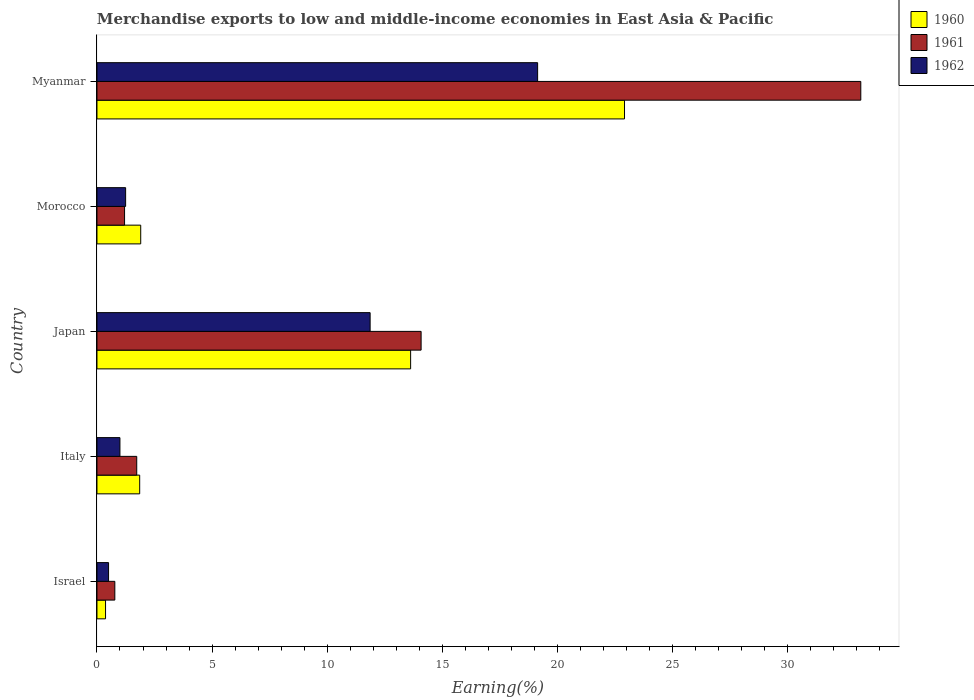How many different coloured bars are there?
Give a very brief answer. 3. How many groups of bars are there?
Provide a short and direct response. 5. How many bars are there on the 2nd tick from the top?
Your response must be concise. 3. How many bars are there on the 2nd tick from the bottom?
Your answer should be compact. 3. In how many cases, is the number of bars for a given country not equal to the number of legend labels?
Provide a succinct answer. 0. What is the percentage of amount earned from merchandise exports in 1961 in Myanmar?
Ensure brevity in your answer.  33.19. Across all countries, what is the maximum percentage of amount earned from merchandise exports in 1960?
Your answer should be very brief. 22.92. Across all countries, what is the minimum percentage of amount earned from merchandise exports in 1960?
Make the answer very short. 0.37. In which country was the percentage of amount earned from merchandise exports in 1960 maximum?
Your response must be concise. Myanmar. In which country was the percentage of amount earned from merchandise exports in 1960 minimum?
Provide a short and direct response. Israel. What is the total percentage of amount earned from merchandise exports in 1960 in the graph?
Your answer should be compact. 40.68. What is the difference between the percentage of amount earned from merchandise exports in 1960 in Italy and that in Japan?
Your answer should be compact. -11.77. What is the difference between the percentage of amount earned from merchandise exports in 1961 in Israel and the percentage of amount earned from merchandise exports in 1962 in Morocco?
Offer a terse response. -0.47. What is the average percentage of amount earned from merchandise exports in 1960 per country?
Make the answer very short. 8.14. What is the difference between the percentage of amount earned from merchandise exports in 1961 and percentage of amount earned from merchandise exports in 1962 in Japan?
Provide a short and direct response. 2.22. In how many countries, is the percentage of amount earned from merchandise exports in 1962 greater than 4 %?
Provide a short and direct response. 2. What is the ratio of the percentage of amount earned from merchandise exports in 1962 in Italy to that in Morocco?
Keep it short and to the point. 0.8. Is the percentage of amount earned from merchandise exports in 1962 in Morocco less than that in Myanmar?
Ensure brevity in your answer.  Yes. Is the difference between the percentage of amount earned from merchandise exports in 1961 in Israel and Italy greater than the difference between the percentage of amount earned from merchandise exports in 1962 in Israel and Italy?
Keep it short and to the point. No. What is the difference between the highest and the second highest percentage of amount earned from merchandise exports in 1962?
Provide a short and direct response. 7.28. What is the difference between the highest and the lowest percentage of amount earned from merchandise exports in 1961?
Keep it short and to the point. 32.41. In how many countries, is the percentage of amount earned from merchandise exports in 1960 greater than the average percentage of amount earned from merchandise exports in 1960 taken over all countries?
Keep it short and to the point. 2. Are all the bars in the graph horizontal?
Keep it short and to the point. Yes. What is the difference between two consecutive major ticks on the X-axis?
Offer a very short reply. 5. Are the values on the major ticks of X-axis written in scientific E-notation?
Your answer should be compact. No. How many legend labels are there?
Make the answer very short. 3. How are the legend labels stacked?
Provide a short and direct response. Vertical. What is the title of the graph?
Keep it short and to the point. Merchandise exports to low and middle-income economies in East Asia & Pacific. What is the label or title of the X-axis?
Keep it short and to the point. Earning(%). What is the label or title of the Y-axis?
Offer a very short reply. Country. What is the Earning(%) of 1960 in Israel?
Give a very brief answer. 0.37. What is the Earning(%) in 1961 in Israel?
Provide a succinct answer. 0.78. What is the Earning(%) in 1962 in Israel?
Keep it short and to the point. 0.5. What is the Earning(%) of 1960 in Italy?
Provide a short and direct response. 1.86. What is the Earning(%) in 1961 in Italy?
Provide a short and direct response. 1.73. What is the Earning(%) of 1962 in Italy?
Ensure brevity in your answer.  1. What is the Earning(%) of 1960 in Japan?
Give a very brief answer. 13.63. What is the Earning(%) in 1961 in Japan?
Offer a terse response. 14.09. What is the Earning(%) of 1962 in Japan?
Your response must be concise. 11.87. What is the Earning(%) of 1960 in Morocco?
Your answer should be compact. 1.9. What is the Earning(%) in 1961 in Morocco?
Your answer should be compact. 1.2. What is the Earning(%) in 1962 in Morocco?
Your answer should be very brief. 1.25. What is the Earning(%) of 1960 in Myanmar?
Provide a short and direct response. 22.92. What is the Earning(%) in 1961 in Myanmar?
Offer a terse response. 33.19. What is the Earning(%) of 1962 in Myanmar?
Provide a short and direct response. 19.15. Across all countries, what is the maximum Earning(%) of 1960?
Your answer should be very brief. 22.92. Across all countries, what is the maximum Earning(%) of 1961?
Your answer should be very brief. 33.19. Across all countries, what is the maximum Earning(%) of 1962?
Your response must be concise. 19.15. Across all countries, what is the minimum Earning(%) in 1960?
Make the answer very short. 0.37. Across all countries, what is the minimum Earning(%) of 1961?
Give a very brief answer. 0.78. Across all countries, what is the minimum Earning(%) in 1962?
Keep it short and to the point. 0.5. What is the total Earning(%) of 1960 in the graph?
Your response must be concise. 40.68. What is the total Earning(%) of 1961 in the graph?
Your answer should be very brief. 50.98. What is the total Earning(%) in 1962 in the graph?
Your answer should be compact. 33.77. What is the difference between the Earning(%) of 1960 in Israel and that in Italy?
Give a very brief answer. -1.48. What is the difference between the Earning(%) of 1961 in Israel and that in Italy?
Keep it short and to the point. -0.95. What is the difference between the Earning(%) of 1962 in Israel and that in Italy?
Provide a succinct answer. -0.49. What is the difference between the Earning(%) of 1960 in Israel and that in Japan?
Provide a short and direct response. -13.26. What is the difference between the Earning(%) of 1961 in Israel and that in Japan?
Provide a succinct answer. -13.31. What is the difference between the Earning(%) in 1962 in Israel and that in Japan?
Offer a very short reply. -11.37. What is the difference between the Earning(%) in 1960 in Israel and that in Morocco?
Make the answer very short. -1.53. What is the difference between the Earning(%) in 1961 in Israel and that in Morocco?
Your answer should be very brief. -0.42. What is the difference between the Earning(%) of 1962 in Israel and that in Morocco?
Offer a terse response. -0.74. What is the difference between the Earning(%) of 1960 in Israel and that in Myanmar?
Make the answer very short. -22.55. What is the difference between the Earning(%) of 1961 in Israel and that in Myanmar?
Provide a short and direct response. -32.41. What is the difference between the Earning(%) in 1962 in Israel and that in Myanmar?
Your response must be concise. -18.64. What is the difference between the Earning(%) of 1960 in Italy and that in Japan?
Ensure brevity in your answer.  -11.77. What is the difference between the Earning(%) of 1961 in Italy and that in Japan?
Provide a short and direct response. -12.36. What is the difference between the Earning(%) of 1962 in Italy and that in Japan?
Your answer should be compact. -10.87. What is the difference between the Earning(%) in 1960 in Italy and that in Morocco?
Make the answer very short. -0.04. What is the difference between the Earning(%) of 1961 in Italy and that in Morocco?
Give a very brief answer. 0.53. What is the difference between the Earning(%) in 1962 in Italy and that in Morocco?
Your answer should be very brief. -0.25. What is the difference between the Earning(%) in 1960 in Italy and that in Myanmar?
Give a very brief answer. -21.07. What is the difference between the Earning(%) of 1961 in Italy and that in Myanmar?
Give a very brief answer. -31.46. What is the difference between the Earning(%) of 1962 in Italy and that in Myanmar?
Offer a very short reply. -18.15. What is the difference between the Earning(%) of 1960 in Japan and that in Morocco?
Ensure brevity in your answer.  11.73. What is the difference between the Earning(%) in 1961 in Japan and that in Morocco?
Offer a very short reply. 12.89. What is the difference between the Earning(%) of 1962 in Japan and that in Morocco?
Offer a very short reply. 10.62. What is the difference between the Earning(%) of 1960 in Japan and that in Myanmar?
Your response must be concise. -9.29. What is the difference between the Earning(%) of 1961 in Japan and that in Myanmar?
Give a very brief answer. -19.11. What is the difference between the Earning(%) in 1962 in Japan and that in Myanmar?
Provide a short and direct response. -7.28. What is the difference between the Earning(%) of 1960 in Morocco and that in Myanmar?
Offer a terse response. -21.02. What is the difference between the Earning(%) of 1961 in Morocco and that in Myanmar?
Provide a succinct answer. -31.99. What is the difference between the Earning(%) of 1962 in Morocco and that in Myanmar?
Keep it short and to the point. -17.9. What is the difference between the Earning(%) in 1960 in Israel and the Earning(%) in 1961 in Italy?
Give a very brief answer. -1.36. What is the difference between the Earning(%) in 1960 in Israel and the Earning(%) in 1962 in Italy?
Provide a short and direct response. -0.63. What is the difference between the Earning(%) in 1961 in Israel and the Earning(%) in 1962 in Italy?
Keep it short and to the point. -0.22. What is the difference between the Earning(%) of 1960 in Israel and the Earning(%) of 1961 in Japan?
Provide a succinct answer. -13.71. What is the difference between the Earning(%) in 1960 in Israel and the Earning(%) in 1962 in Japan?
Provide a short and direct response. -11.5. What is the difference between the Earning(%) in 1961 in Israel and the Earning(%) in 1962 in Japan?
Give a very brief answer. -11.09. What is the difference between the Earning(%) of 1960 in Israel and the Earning(%) of 1961 in Morocco?
Your response must be concise. -0.83. What is the difference between the Earning(%) of 1960 in Israel and the Earning(%) of 1962 in Morocco?
Ensure brevity in your answer.  -0.87. What is the difference between the Earning(%) in 1961 in Israel and the Earning(%) in 1962 in Morocco?
Offer a very short reply. -0.47. What is the difference between the Earning(%) in 1960 in Israel and the Earning(%) in 1961 in Myanmar?
Keep it short and to the point. -32.82. What is the difference between the Earning(%) in 1960 in Israel and the Earning(%) in 1962 in Myanmar?
Offer a terse response. -18.78. What is the difference between the Earning(%) of 1961 in Israel and the Earning(%) of 1962 in Myanmar?
Keep it short and to the point. -18.37. What is the difference between the Earning(%) of 1960 in Italy and the Earning(%) of 1961 in Japan?
Ensure brevity in your answer.  -12.23. What is the difference between the Earning(%) in 1960 in Italy and the Earning(%) in 1962 in Japan?
Provide a succinct answer. -10.01. What is the difference between the Earning(%) of 1961 in Italy and the Earning(%) of 1962 in Japan?
Offer a very short reply. -10.14. What is the difference between the Earning(%) in 1960 in Italy and the Earning(%) in 1961 in Morocco?
Ensure brevity in your answer.  0.66. What is the difference between the Earning(%) in 1960 in Italy and the Earning(%) in 1962 in Morocco?
Offer a terse response. 0.61. What is the difference between the Earning(%) in 1961 in Italy and the Earning(%) in 1962 in Morocco?
Ensure brevity in your answer.  0.48. What is the difference between the Earning(%) in 1960 in Italy and the Earning(%) in 1961 in Myanmar?
Keep it short and to the point. -31.33. What is the difference between the Earning(%) of 1960 in Italy and the Earning(%) of 1962 in Myanmar?
Offer a very short reply. -17.29. What is the difference between the Earning(%) of 1961 in Italy and the Earning(%) of 1962 in Myanmar?
Your response must be concise. -17.42. What is the difference between the Earning(%) in 1960 in Japan and the Earning(%) in 1961 in Morocco?
Give a very brief answer. 12.43. What is the difference between the Earning(%) in 1960 in Japan and the Earning(%) in 1962 in Morocco?
Keep it short and to the point. 12.38. What is the difference between the Earning(%) of 1961 in Japan and the Earning(%) of 1962 in Morocco?
Make the answer very short. 12.84. What is the difference between the Earning(%) of 1960 in Japan and the Earning(%) of 1961 in Myanmar?
Offer a very short reply. -19.56. What is the difference between the Earning(%) in 1960 in Japan and the Earning(%) in 1962 in Myanmar?
Offer a very short reply. -5.52. What is the difference between the Earning(%) of 1961 in Japan and the Earning(%) of 1962 in Myanmar?
Your response must be concise. -5.06. What is the difference between the Earning(%) of 1960 in Morocco and the Earning(%) of 1961 in Myanmar?
Your answer should be compact. -31.29. What is the difference between the Earning(%) of 1960 in Morocco and the Earning(%) of 1962 in Myanmar?
Offer a terse response. -17.25. What is the difference between the Earning(%) in 1961 in Morocco and the Earning(%) in 1962 in Myanmar?
Make the answer very short. -17.95. What is the average Earning(%) in 1960 per country?
Offer a very short reply. 8.14. What is the average Earning(%) of 1961 per country?
Keep it short and to the point. 10.2. What is the average Earning(%) of 1962 per country?
Offer a terse response. 6.75. What is the difference between the Earning(%) in 1960 and Earning(%) in 1961 in Israel?
Your answer should be compact. -0.4. What is the difference between the Earning(%) in 1960 and Earning(%) in 1962 in Israel?
Your answer should be very brief. -0.13. What is the difference between the Earning(%) in 1961 and Earning(%) in 1962 in Israel?
Offer a very short reply. 0.27. What is the difference between the Earning(%) in 1960 and Earning(%) in 1961 in Italy?
Your answer should be very brief. 0.13. What is the difference between the Earning(%) in 1960 and Earning(%) in 1962 in Italy?
Your answer should be compact. 0.86. What is the difference between the Earning(%) in 1961 and Earning(%) in 1962 in Italy?
Give a very brief answer. 0.73. What is the difference between the Earning(%) in 1960 and Earning(%) in 1961 in Japan?
Offer a very short reply. -0.46. What is the difference between the Earning(%) of 1960 and Earning(%) of 1962 in Japan?
Provide a succinct answer. 1.76. What is the difference between the Earning(%) of 1961 and Earning(%) of 1962 in Japan?
Your answer should be very brief. 2.22. What is the difference between the Earning(%) of 1960 and Earning(%) of 1961 in Morocco?
Provide a short and direct response. 0.7. What is the difference between the Earning(%) in 1960 and Earning(%) in 1962 in Morocco?
Make the answer very short. 0.66. What is the difference between the Earning(%) in 1961 and Earning(%) in 1962 in Morocco?
Give a very brief answer. -0.05. What is the difference between the Earning(%) in 1960 and Earning(%) in 1961 in Myanmar?
Your response must be concise. -10.27. What is the difference between the Earning(%) of 1960 and Earning(%) of 1962 in Myanmar?
Make the answer very short. 3.78. What is the difference between the Earning(%) of 1961 and Earning(%) of 1962 in Myanmar?
Your response must be concise. 14.04. What is the ratio of the Earning(%) of 1960 in Israel to that in Italy?
Provide a short and direct response. 0.2. What is the ratio of the Earning(%) in 1961 in Israel to that in Italy?
Provide a succinct answer. 0.45. What is the ratio of the Earning(%) of 1962 in Israel to that in Italy?
Your answer should be very brief. 0.51. What is the ratio of the Earning(%) in 1960 in Israel to that in Japan?
Keep it short and to the point. 0.03. What is the ratio of the Earning(%) of 1961 in Israel to that in Japan?
Ensure brevity in your answer.  0.06. What is the ratio of the Earning(%) of 1962 in Israel to that in Japan?
Make the answer very short. 0.04. What is the ratio of the Earning(%) of 1960 in Israel to that in Morocco?
Your answer should be very brief. 0.2. What is the ratio of the Earning(%) in 1961 in Israel to that in Morocco?
Offer a terse response. 0.65. What is the ratio of the Earning(%) of 1962 in Israel to that in Morocco?
Your answer should be very brief. 0.4. What is the ratio of the Earning(%) of 1960 in Israel to that in Myanmar?
Provide a short and direct response. 0.02. What is the ratio of the Earning(%) of 1961 in Israel to that in Myanmar?
Ensure brevity in your answer.  0.02. What is the ratio of the Earning(%) of 1962 in Israel to that in Myanmar?
Provide a short and direct response. 0.03. What is the ratio of the Earning(%) in 1960 in Italy to that in Japan?
Your answer should be compact. 0.14. What is the ratio of the Earning(%) in 1961 in Italy to that in Japan?
Your answer should be compact. 0.12. What is the ratio of the Earning(%) of 1962 in Italy to that in Japan?
Provide a succinct answer. 0.08. What is the ratio of the Earning(%) of 1960 in Italy to that in Morocco?
Offer a very short reply. 0.98. What is the ratio of the Earning(%) of 1961 in Italy to that in Morocco?
Offer a very short reply. 1.44. What is the ratio of the Earning(%) of 1962 in Italy to that in Morocco?
Offer a very short reply. 0.8. What is the ratio of the Earning(%) of 1960 in Italy to that in Myanmar?
Your answer should be very brief. 0.08. What is the ratio of the Earning(%) in 1961 in Italy to that in Myanmar?
Provide a succinct answer. 0.05. What is the ratio of the Earning(%) of 1962 in Italy to that in Myanmar?
Offer a very short reply. 0.05. What is the ratio of the Earning(%) of 1960 in Japan to that in Morocco?
Your response must be concise. 7.17. What is the ratio of the Earning(%) in 1961 in Japan to that in Morocco?
Make the answer very short. 11.75. What is the ratio of the Earning(%) of 1962 in Japan to that in Morocco?
Give a very brief answer. 9.53. What is the ratio of the Earning(%) of 1960 in Japan to that in Myanmar?
Ensure brevity in your answer.  0.59. What is the ratio of the Earning(%) of 1961 in Japan to that in Myanmar?
Your response must be concise. 0.42. What is the ratio of the Earning(%) of 1962 in Japan to that in Myanmar?
Keep it short and to the point. 0.62. What is the ratio of the Earning(%) of 1960 in Morocco to that in Myanmar?
Your answer should be compact. 0.08. What is the ratio of the Earning(%) in 1961 in Morocco to that in Myanmar?
Make the answer very short. 0.04. What is the ratio of the Earning(%) of 1962 in Morocco to that in Myanmar?
Give a very brief answer. 0.07. What is the difference between the highest and the second highest Earning(%) of 1960?
Provide a short and direct response. 9.29. What is the difference between the highest and the second highest Earning(%) in 1961?
Your answer should be very brief. 19.11. What is the difference between the highest and the second highest Earning(%) of 1962?
Ensure brevity in your answer.  7.28. What is the difference between the highest and the lowest Earning(%) of 1960?
Your answer should be very brief. 22.55. What is the difference between the highest and the lowest Earning(%) of 1961?
Offer a terse response. 32.41. What is the difference between the highest and the lowest Earning(%) in 1962?
Your answer should be compact. 18.64. 